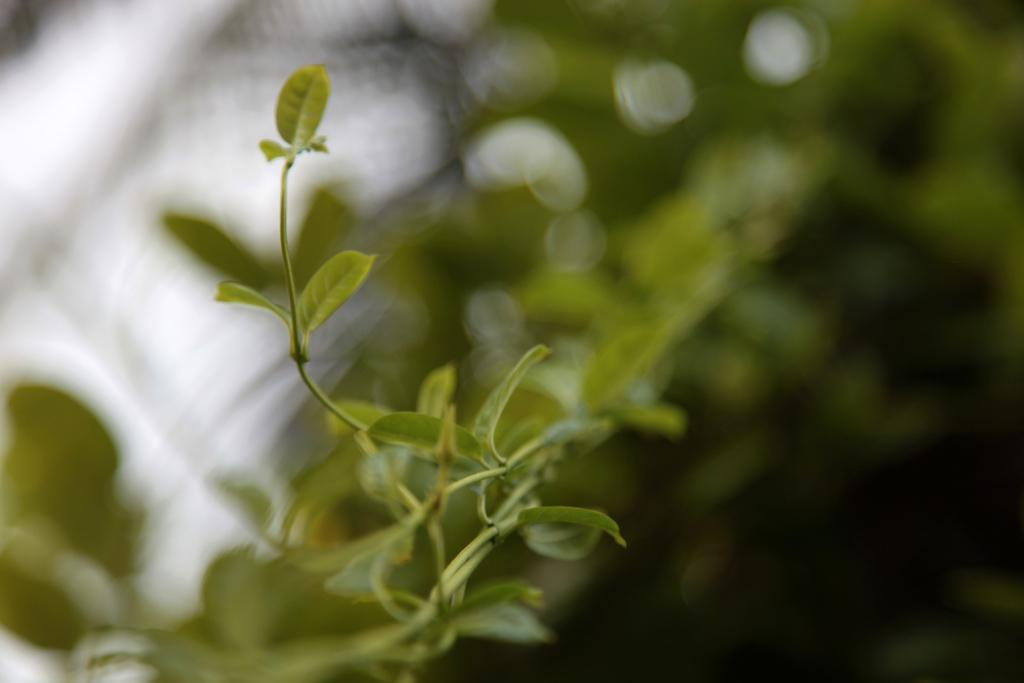What type of vegetation can be seen in the image? There are trees in the image. Can you describe the background of the image? The background of the image is blurred. Is there any quicksand visible in the image? There is no quicksand present in the image. What type of powder is being used to care for the trees in the image? There is no mention of any powder or care for the trees in the image. 